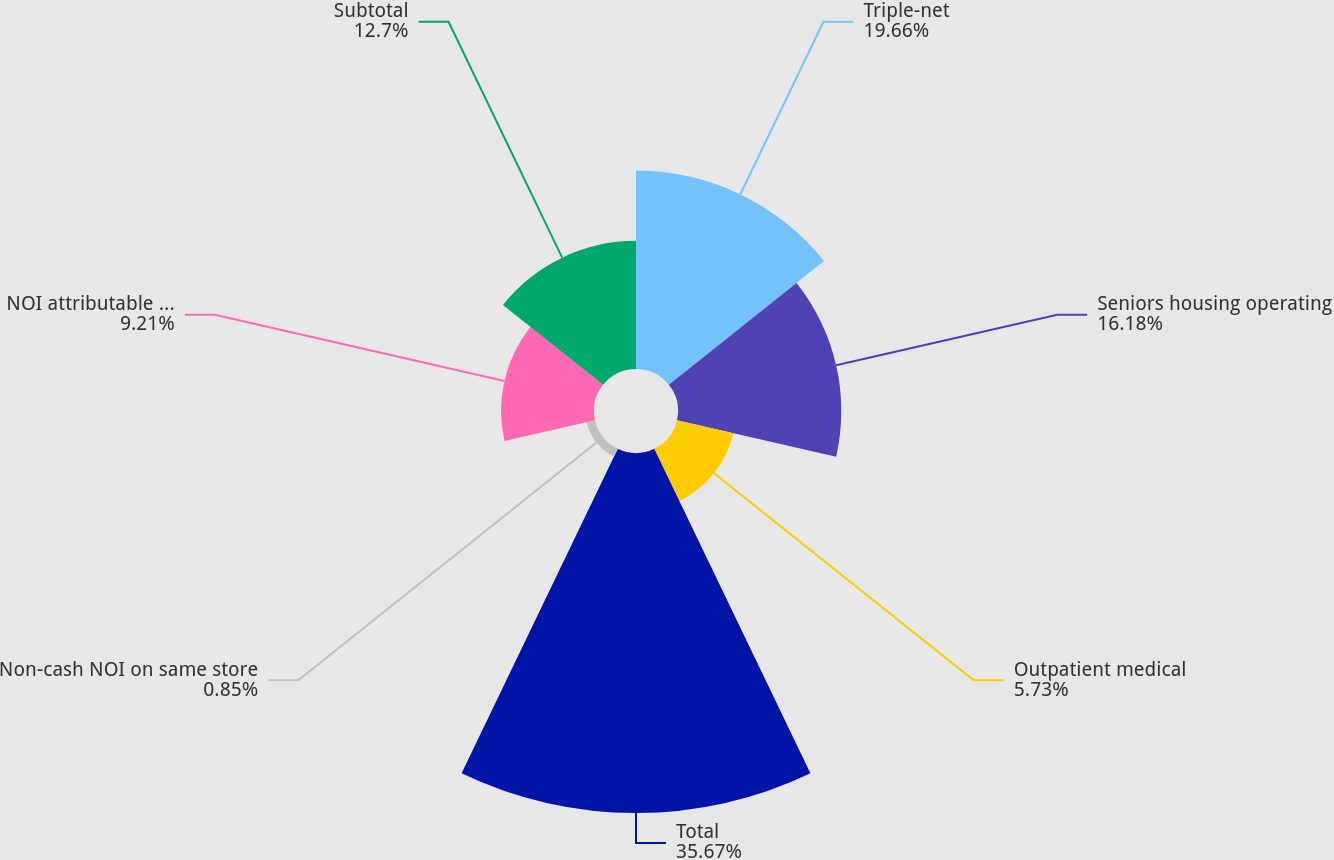<chart> <loc_0><loc_0><loc_500><loc_500><pie_chart><fcel>Triple-net<fcel>Seniors housing operating<fcel>Outpatient medical<fcel>Total<fcel>Non-cash NOI on same store<fcel>NOI attributable to non same<fcel>Subtotal<nl><fcel>19.66%<fcel>16.18%<fcel>5.73%<fcel>35.67%<fcel>0.85%<fcel>9.21%<fcel>12.7%<nl></chart> 